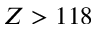Convert formula to latex. <formula><loc_0><loc_0><loc_500><loc_500>Z > 1 1 8</formula> 